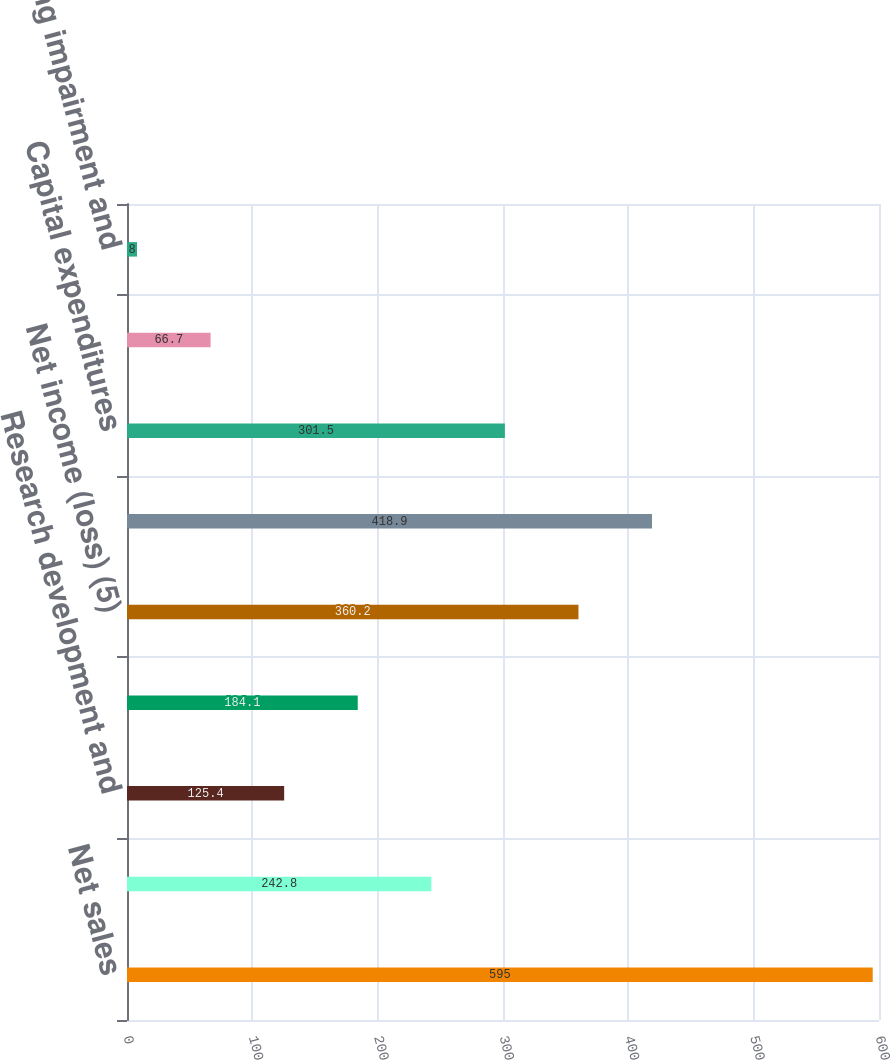Convert chart to OTSL. <chart><loc_0><loc_0><loc_500><loc_500><bar_chart><fcel>Net sales<fcel>Depreciation (1)<fcel>Research development and<fcel>Income tax (provision) benefit<fcel>Net income (loss) (5)<fcel>Segment assets (6)<fcel>Capital expenditures<fcel>expenses (2)<fcel>Restructuring impairment and<nl><fcel>595<fcel>242.8<fcel>125.4<fcel>184.1<fcel>360.2<fcel>418.9<fcel>301.5<fcel>66.7<fcel>8<nl></chart> 